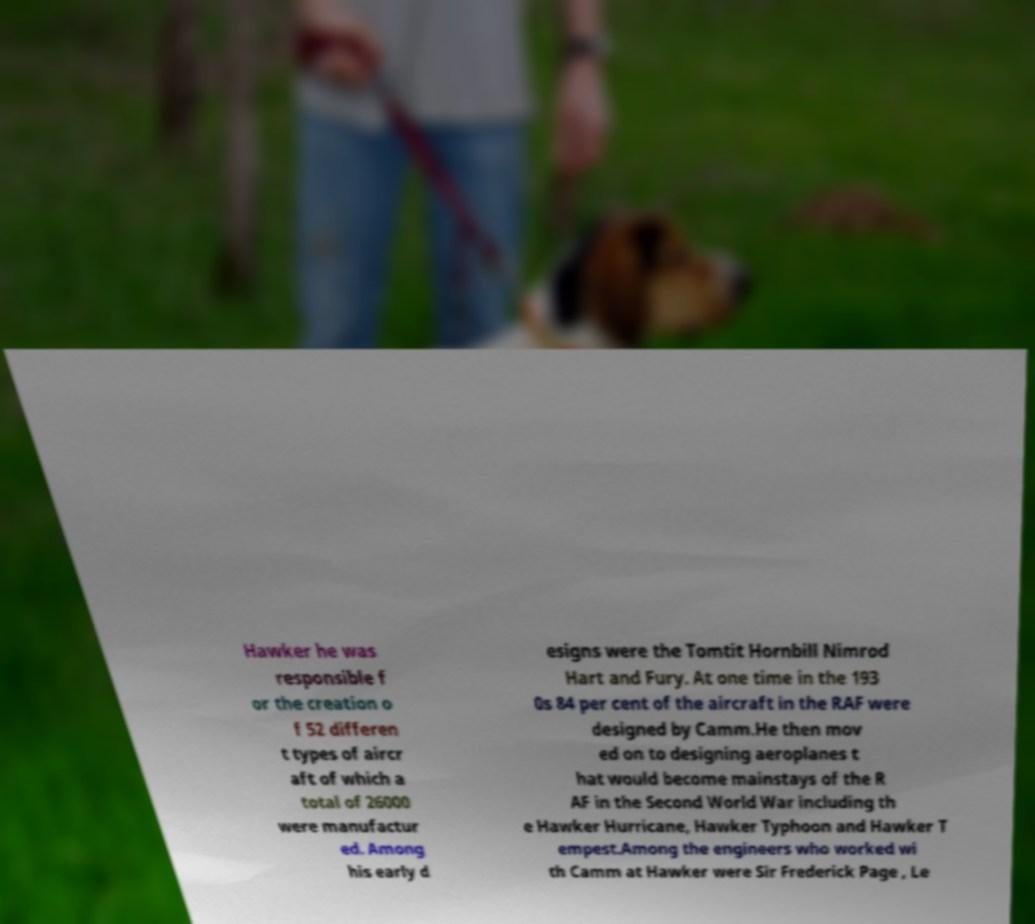I need the written content from this picture converted into text. Can you do that? Hawker he was responsible f or the creation o f 52 differen t types of aircr aft of which a total of 26000 were manufactur ed. Among his early d esigns were the Tomtit Hornbill Nimrod Hart and Fury. At one time in the 193 0s 84 per cent of the aircraft in the RAF were designed by Camm.He then mov ed on to designing aeroplanes t hat would become mainstays of the R AF in the Second World War including th e Hawker Hurricane, Hawker Typhoon and Hawker T empest.Among the engineers who worked wi th Camm at Hawker were Sir Frederick Page , Le 